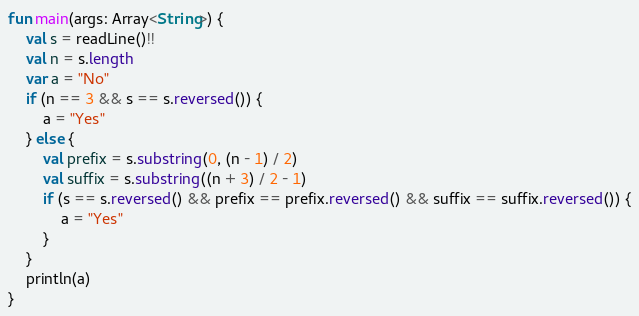<code> <loc_0><loc_0><loc_500><loc_500><_Kotlin_>fun main(args: Array<String>) {
    val s = readLine()!!
    val n = s.length
    var a = "No"
    if (n == 3 && s == s.reversed()) {
        a = "Yes"
    } else {
        val prefix = s.substring(0, (n - 1) / 2)
        val suffix = s.substring((n + 3) / 2 - 1)
        if (s == s.reversed() && prefix == prefix.reversed() && suffix == suffix.reversed()) {
            a = "Yes"
        }
    }
    println(a)
}</code> 